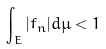<formula> <loc_0><loc_0><loc_500><loc_500>\int _ { E } | f _ { n } | d \mu < 1</formula> 